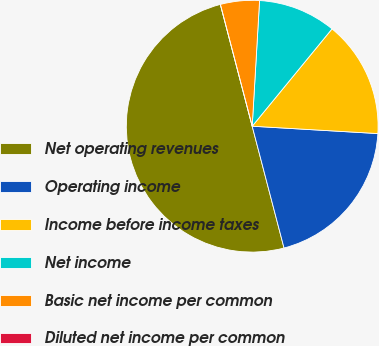Convert chart to OTSL. <chart><loc_0><loc_0><loc_500><loc_500><pie_chart><fcel>Net operating revenues<fcel>Operating income<fcel>Income before income taxes<fcel>Net income<fcel>Basic net income per common<fcel>Diluted net income per common<nl><fcel>50.0%<fcel>20.0%<fcel>15.0%<fcel>10.0%<fcel>5.0%<fcel>0.0%<nl></chart> 